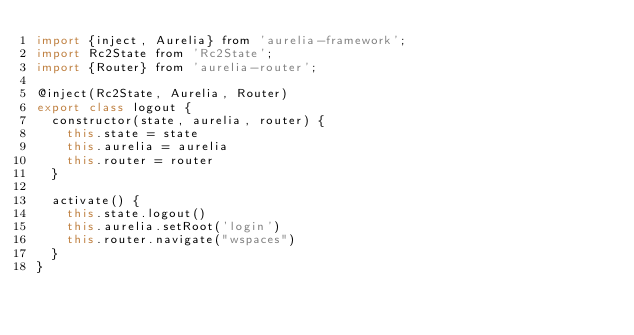<code> <loc_0><loc_0><loc_500><loc_500><_JavaScript_>import {inject, Aurelia} from 'aurelia-framework';
import Rc2State from 'Rc2State';
import {Router} from 'aurelia-router';

@inject(Rc2State, Aurelia, Router)
export class logout {
	constructor(state, aurelia, router) {
		this.state = state
		this.aurelia = aurelia
		this.router = router
	}
	
	activate() {
		this.state.logout()
		this.aurelia.setRoot('login')
		this.router.navigate("wspaces")
	}
}

</code> 